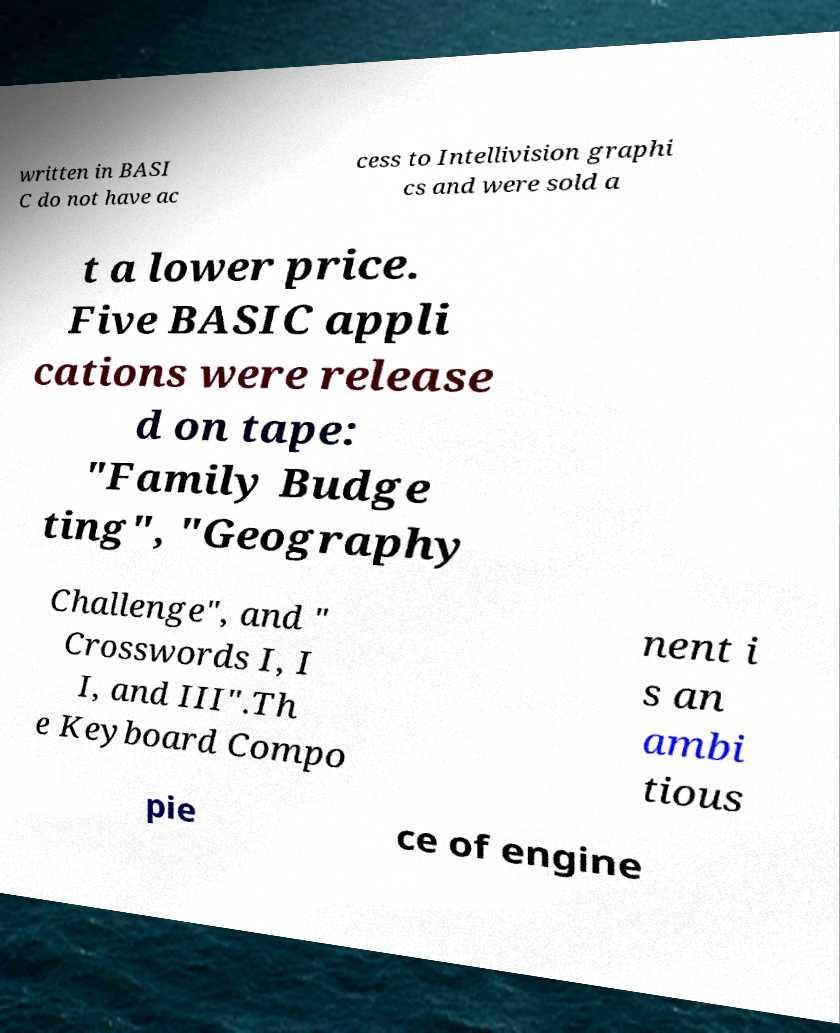Please identify and transcribe the text found in this image. written in BASI C do not have ac cess to Intellivision graphi cs and were sold a t a lower price. Five BASIC appli cations were release d on tape: "Family Budge ting", "Geography Challenge", and " Crosswords I, I I, and III".Th e Keyboard Compo nent i s an ambi tious pie ce of engine 